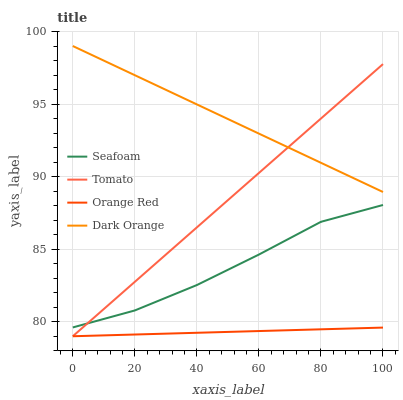Does Orange Red have the minimum area under the curve?
Answer yes or no. Yes. Does Dark Orange have the maximum area under the curve?
Answer yes or no. Yes. Does Seafoam have the minimum area under the curve?
Answer yes or no. No. Does Seafoam have the maximum area under the curve?
Answer yes or no. No. Is Dark Orange the smoothest?
Answer yes or no. Yes. Is Seafoam the roughest?
Answer yes or no. Yes. Is Seafoam the smoothest?
Answer yes or no. No. Is Dark Orange the roughest?
Answer yes or no. No. Does Seafoam have the lowest value?
Answer yes or no. No. Does Seafoam have the highest value?
Answer yes or no. No. Is Orange Red less than Seafoam?
Answer yes or no. Yes. Is Dark Orange greater than Orange Red?
Answer yes or no. Yes. Does Orange Red intersect Seafoam?
Answer yes or no. No. 